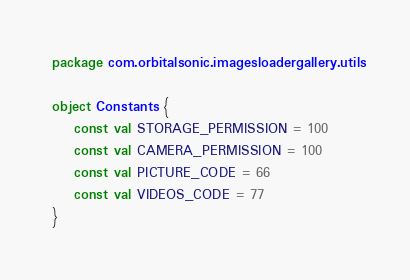<code> <loc_0><loc_0><loc_500><loc_500><_Kotlin_>package com.orbitalsonic.imagesloadergallery.utils

object Constants {
    const val STORAGE_PERMISSION = 100
    const val CAMERA_PERMISSION = 100
    const val PICTURE_CODE = 66
    const val VIDEOS_CODE = 77
}</code> 